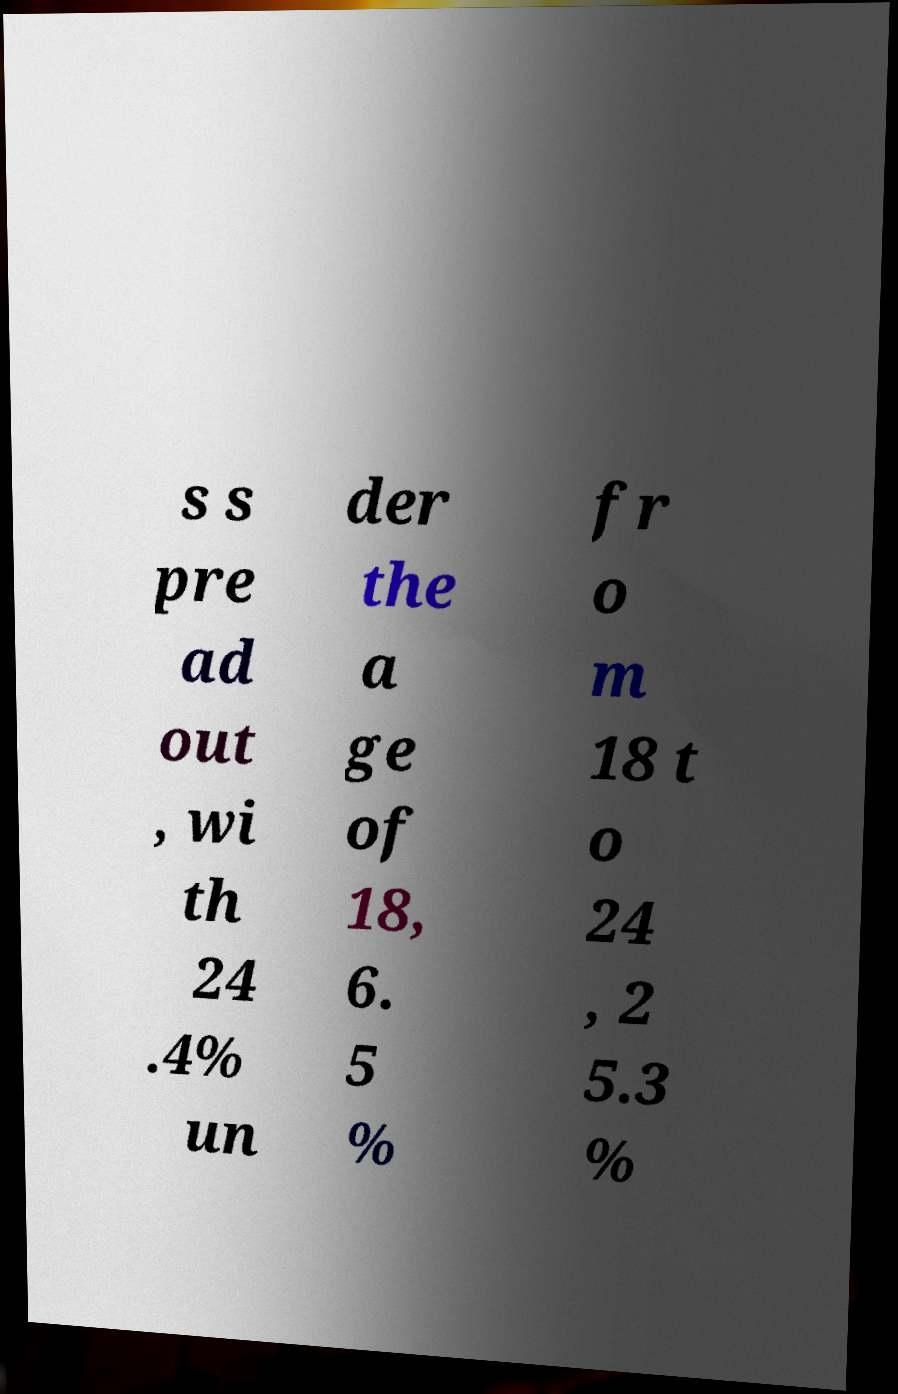Can you accurately transcribe the text from the provided image for me? s s pre ad out , wi th 24 .4% un der the a ge of 18, 6. 5 % fr o m 18 t o 24 , 2 5.3 % 